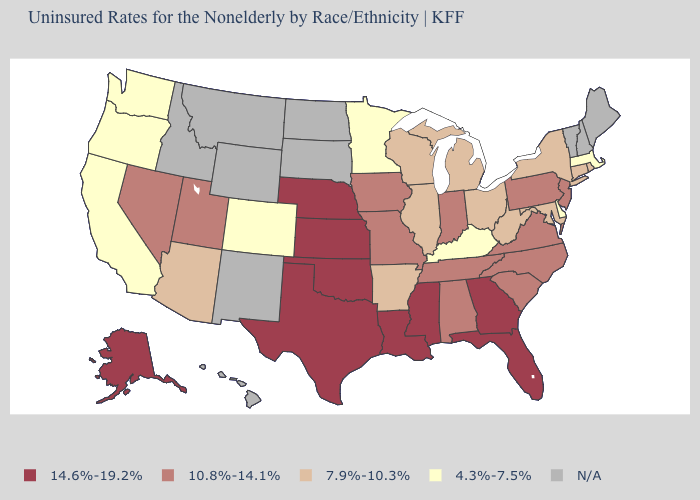Which states have the lowest value in the South?
Short answer required. Delaware, Kentucky. What is the highest value in states that border West Virginia?
Write a very short answer. 10.8%-14.1%. What is the value of Connecticut?
Be succinct. 7.9%-10.3%. Name the states that have a value in the range 7.9%-10.3%?
Be succinct. Arizona, Arkansas, Connecticut, Illinois, Maryland, Michigan, New York, Ohio, Rhode Island, West Virginia, Wisconsin. Name the states that have a value in the range N/A?
Give a very brief answer. Hawaii, Idaho, Maine, Montana, New Hampshire, New Mexico, North Dakota, South Dakota, Vermont, Wyoming. Is the legend a continuous bar?
Short answer required. No. What is the value of Indiana?
Keep it brief. 10.8%-14.1%. What is the value of Washington?
Give a very brief answer. 4.3%-7.5%. Name the states that have a value in the range 10.8%-14.1%?
Write a very short answer. Alabama, Indiana, Iowa, Missouri, Nevada, New Jersey, North Carolina, Pennsylvania, South Carolina, Tennessee, Utah, Virginia. What is the highest value in states that border West Virginia?
Be succinct. 10.8%-14.1%. Which states have the highest value in the USA?
Be succinct. Alaska, Florida, Georgia, Kansas, Louisiana, Mississippi, Nebraska, Oklahoma, Texas. Does the first symbol in the legend represent the smallest category?
Give a very brief answer. No. Name the states that have a value in the range 4.3%-7.5%?
Short answer required. California, Colorado, Delaware, Kentucky, Massachusetts, Minnesota, Oregon, Washington. Does California have the lowest value in the USA?
Quick response, please. Yes. Does the first symbol in the legend represent the smallest category?
Concise answer only. No. 